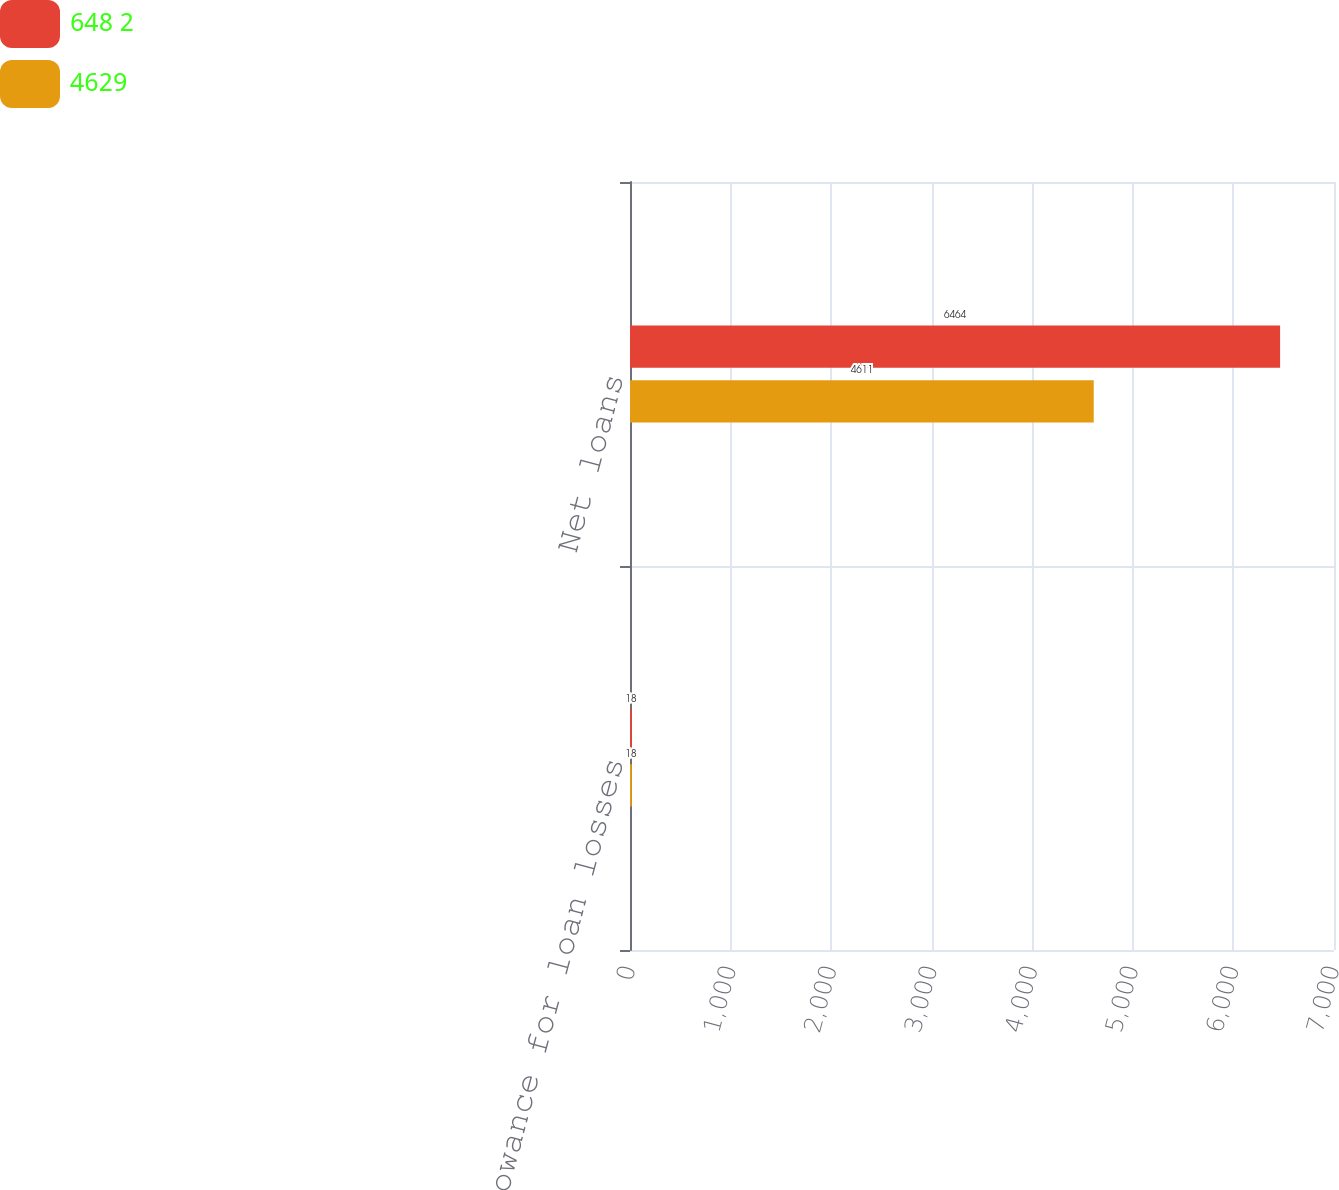Convert chart. <chart><loc_0><loc_0><loc_500><loc_500><stacked_bar_chart><ecel><fcel>Less allowance for loan losses<fcel>Net loans<nl><fcel>648 2<fcel>18<fcel>6464<nl><fcel>4629<fcel>18<fcel>4611<nl></chart> 